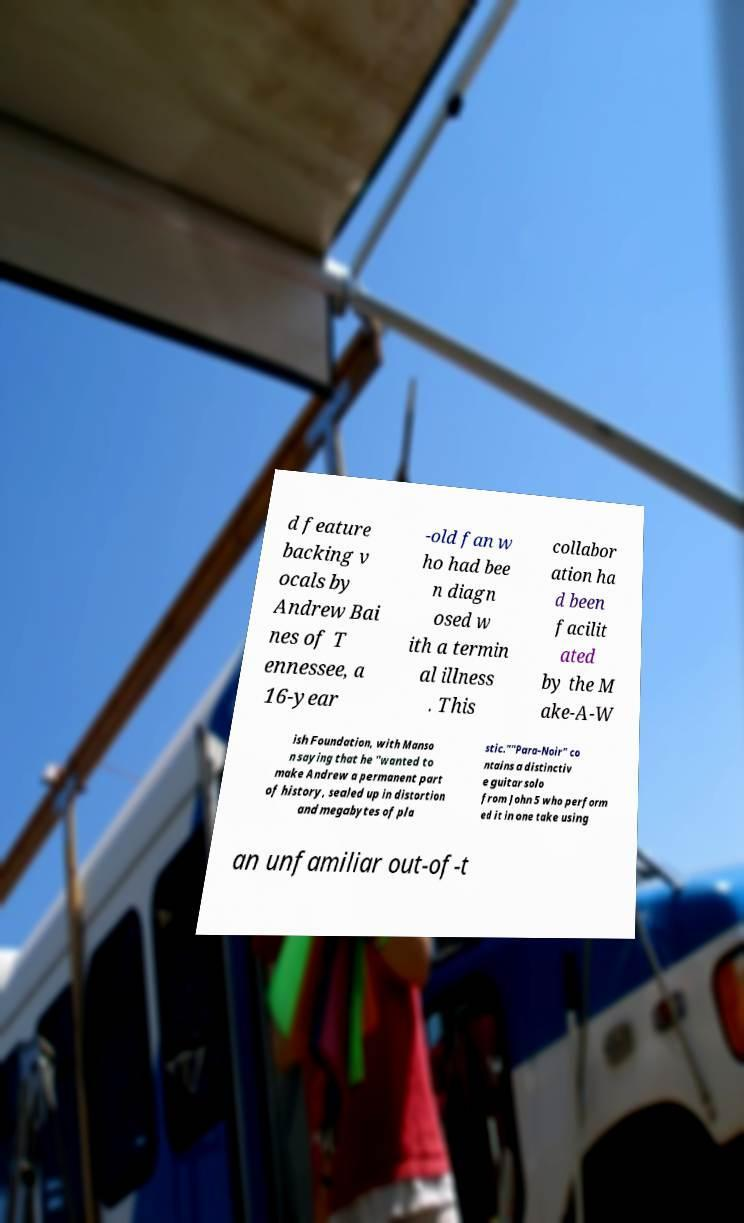Could you assist in decoding the text presented in this image and type it out clearly? d feature backing v ocals by Andrew Bai nes of T ennessee, a 16-year -old fan w ho had bee n diagn osed w ith a termin al illness . This collabor ation ha d been facilit ated by the M ake-A-W ish Foundation, with Manso n saying that he "wanted to make Andrew a permanent part of history, sealed up in distortion and megabytes of pla stic.""Para-Noir" co ntains a distinctiv e guitar solo from John 5 who perform ed it in one take using an unfamiliar out-of-t 